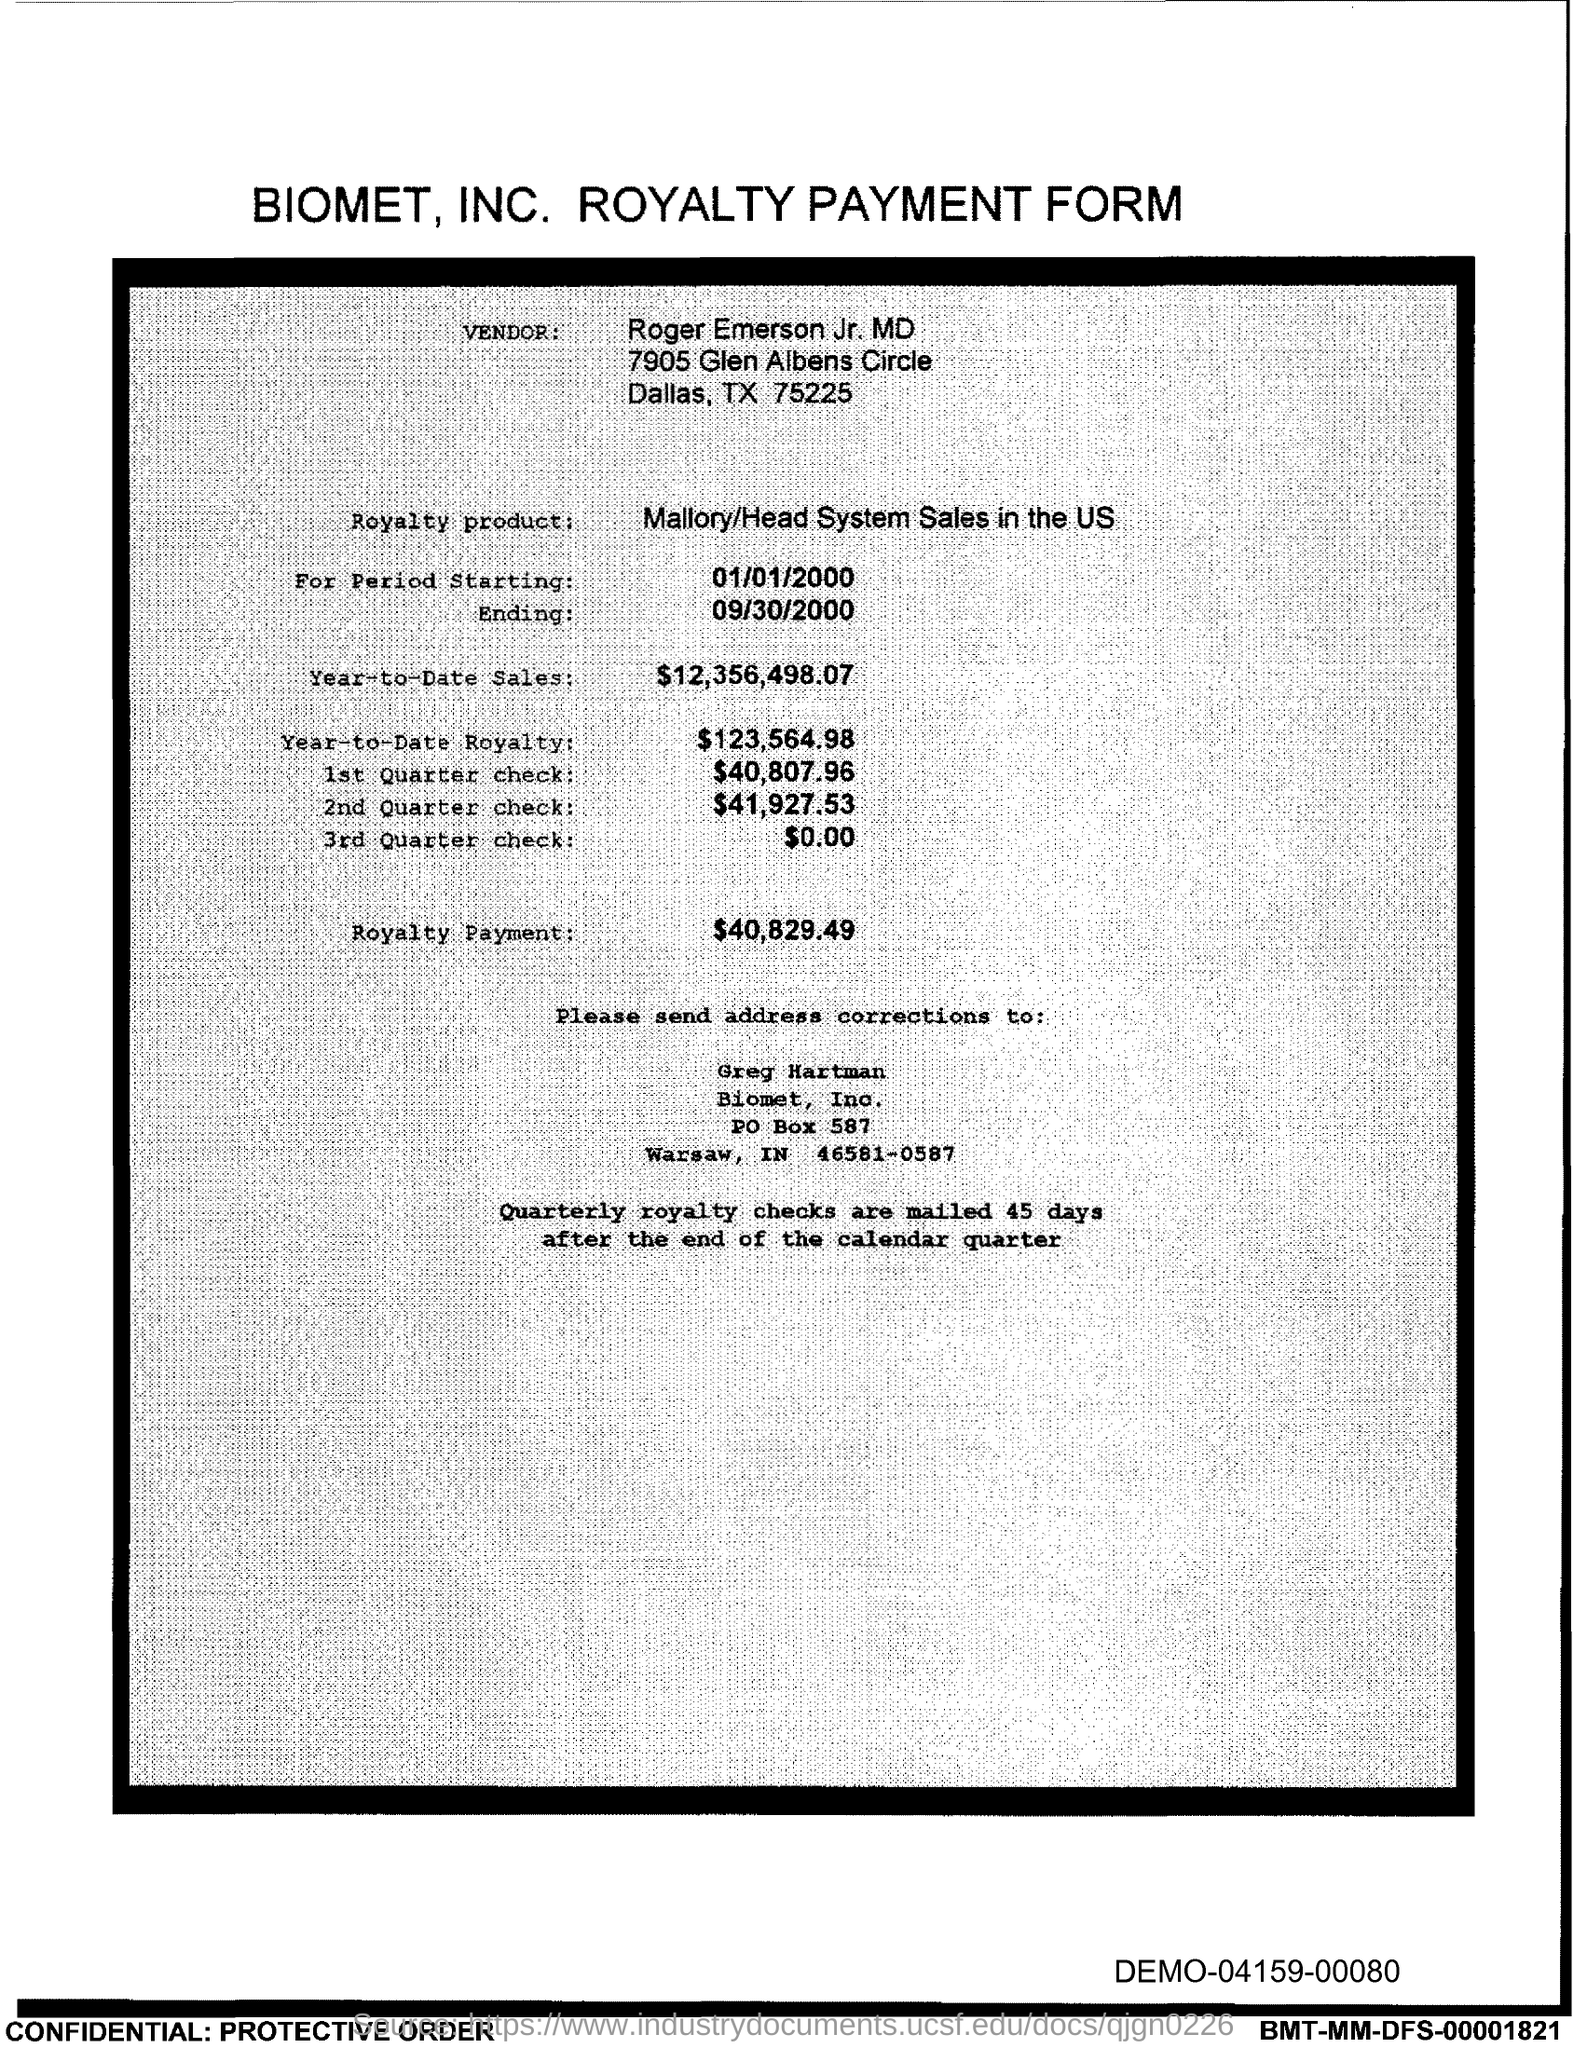Give some essential details in this illustration. The amount of the third quarter check given in the form is $0.00. As of today, the year-to-date royalty for the product is $123,564.98. The amount of the 1st quarter check mentioned in the form is $40,807.96. The start date of the royalty period is January 1, 2000. The year-to-date sales of the royalty product are $12,356,498.07. 